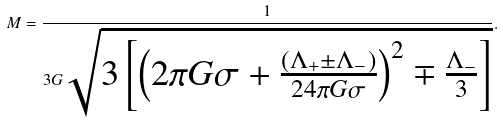<formula> <loc_0><loc_0><loc_500><loc_500>M = \frac { 1 } { 3 G \sqrt { 3 \left [ \left ( 2 \pi G \sigma + \frac { ( \Lambda _ { + } \pm \Lambda _ { - } ) } { 2 4 \pi G \sigma } \right ) ^ { 2 } \mp \frac { \Lambda _ { - } } { 3 } \right ] } } .</formula> 